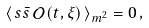<formula> <loc_0><loc_0><loc_500><loc_500>\left \langle \, s \bar { s } \, \mathcal { O } ( t , \xi ) \, \right \rangle _ { m ^ { 2 } } = 0 \, ,</formula> 